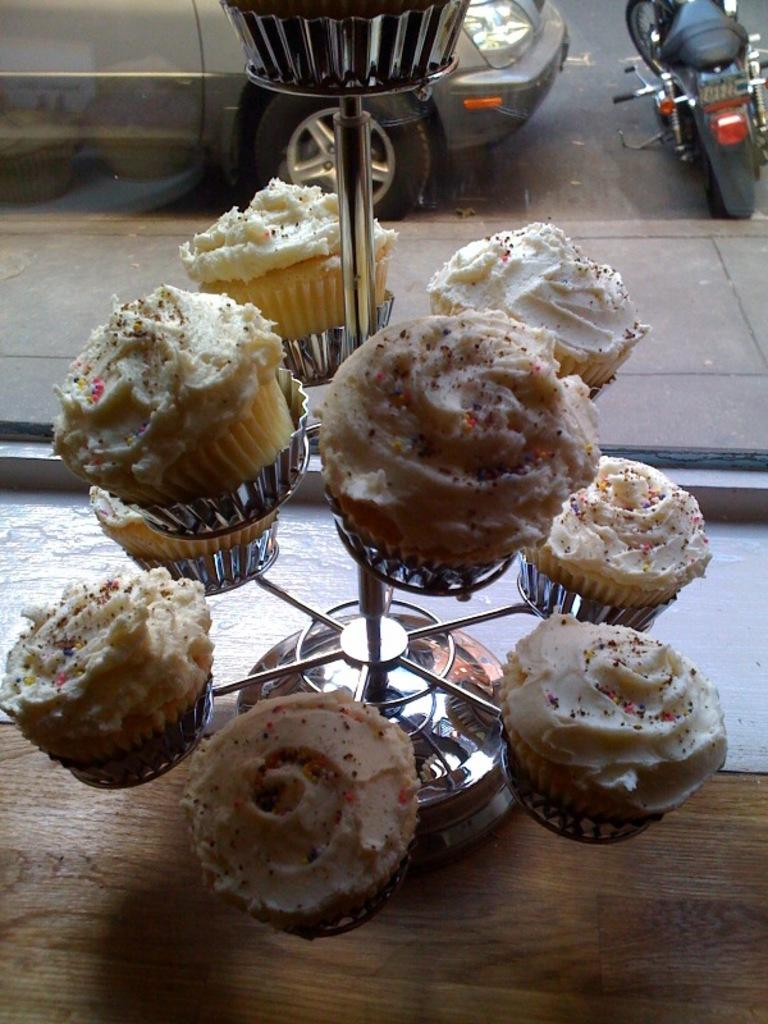What is the main object in the image? There is a stand in the image. What is on the stand? There are cupcakes on the stand. What can be seen in the background of the image? There is a car and a bike in the background of the image. What month is it in the image? The month is not mentioned or depicted in the image. How much wealth is displayed in the image? The image does not show any indication of wealth. 